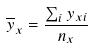<formula> <loc_0><loc_0><loc_500><loc_500>\overline { y } _ { x } = \frac { \sum _ { i } y _ { x i } } { n _ { x } }</formula> 